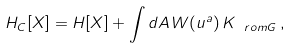<formula> <loc_0><loc_0><loc_500><loc_500>H _ { C } [ { X } ] = H [ { X } ] + \int d A \, W ( u ^ { a } ) \, K _ { \ r o m G } \, ,</formula> 